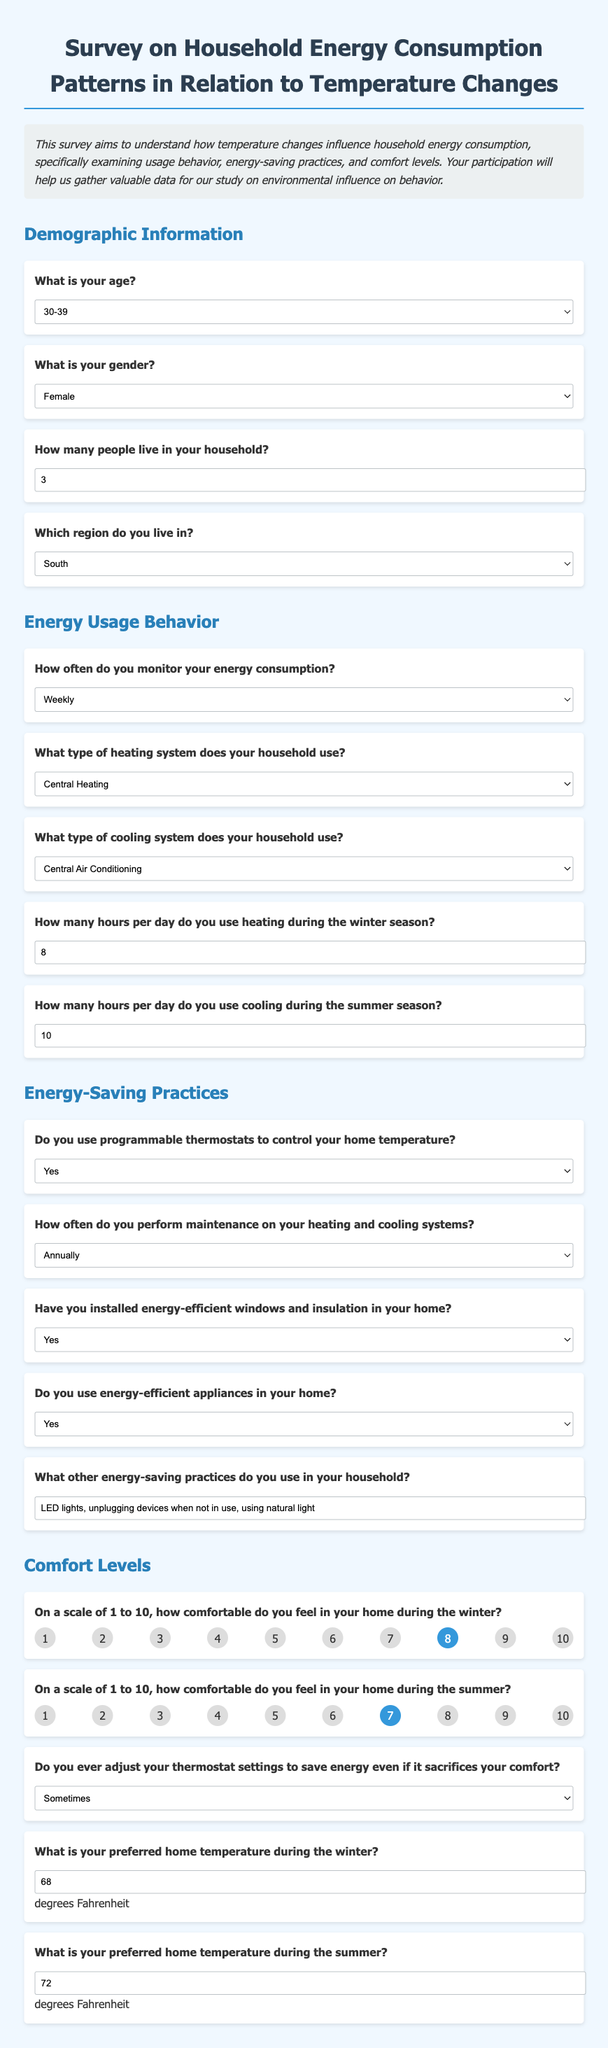What is your age? The document provides demographic information, including age options that participants can choose from.
Answer: 30-39 What type of heating system does your household use? This question asks respondents to select their heating system from options provided in the survey.
Answer: Central Heating How many hours per day do you use cooling during the summer season? The survey includes input for how many hours cooling is used, specifically asking for a numerical response.
Answer: 10 Do you use programmable thermostats to control your home temperature? A yes or no question regarding energy-saving practices mentioned in the survey.
Answer: Yes On a scale of 1 to 10, how comfortable do you feel in your home during the winter? This question requires a rating selection from respondents indicating their comfort level during winter.
Answer: 8 Which region do you live in? The survey includes regions as options for participants to identify their residing area.
Answer: South How often do you monitor your energy consumption? This asks participants to choose from a frequency scale regarding their energy consumption monitoring habits.
Answer: Weekly What is your preferred home temperature during the summer? This question requires a numerical input indicating the desired temperature in Fahrenheit for summer, as provided in the survey.
Answer: 72 